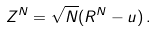<formula> <loc_0><loc_0><loc_500><loc_500>Z ^ { N } = \sqrt { N } ( R ^ { N } - u ) \, .</formula> 